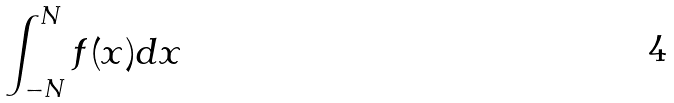<formula> <loc_0><loc_0><loc_500><loc_500>\int _ { - N } ^ { N } f ( x ) d x</formula> 